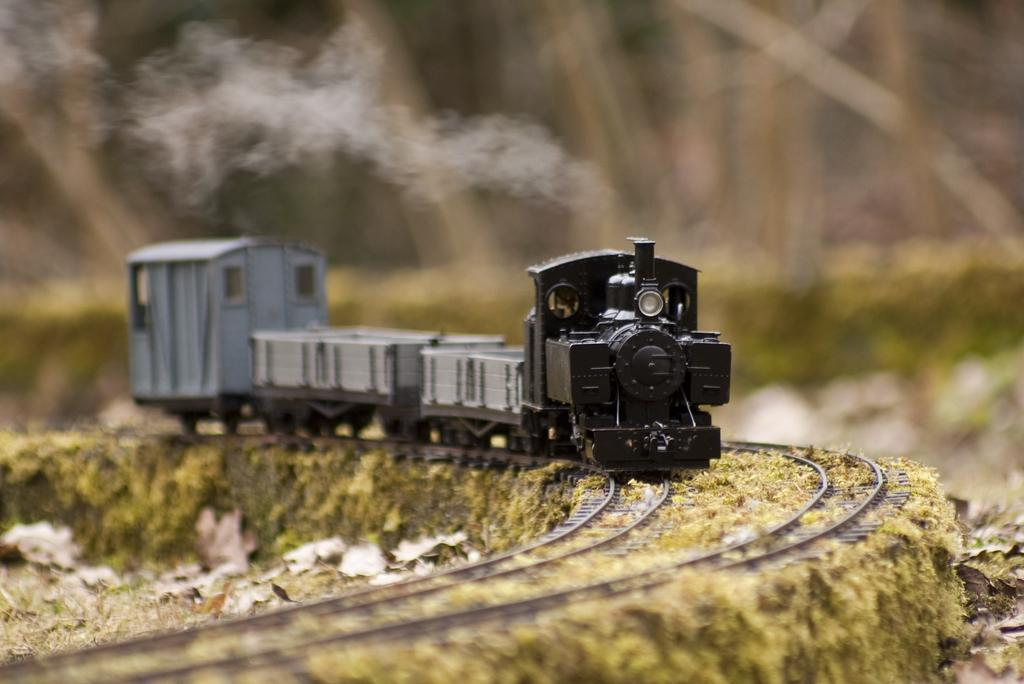What is the main subject of the image? The main subject of the image is a toy train on the track. What can be seen on the ground in the image? Dried leaves are present on the ground in the image. What is visible coming out of the toy train in the image? There is smoke visible in the image. How would you describe the background of the image? The background of the image is blurry. What is the rate of growth of the stem in the image? There is no stem present in the image, so it's not possible to determine the rate of growth. 